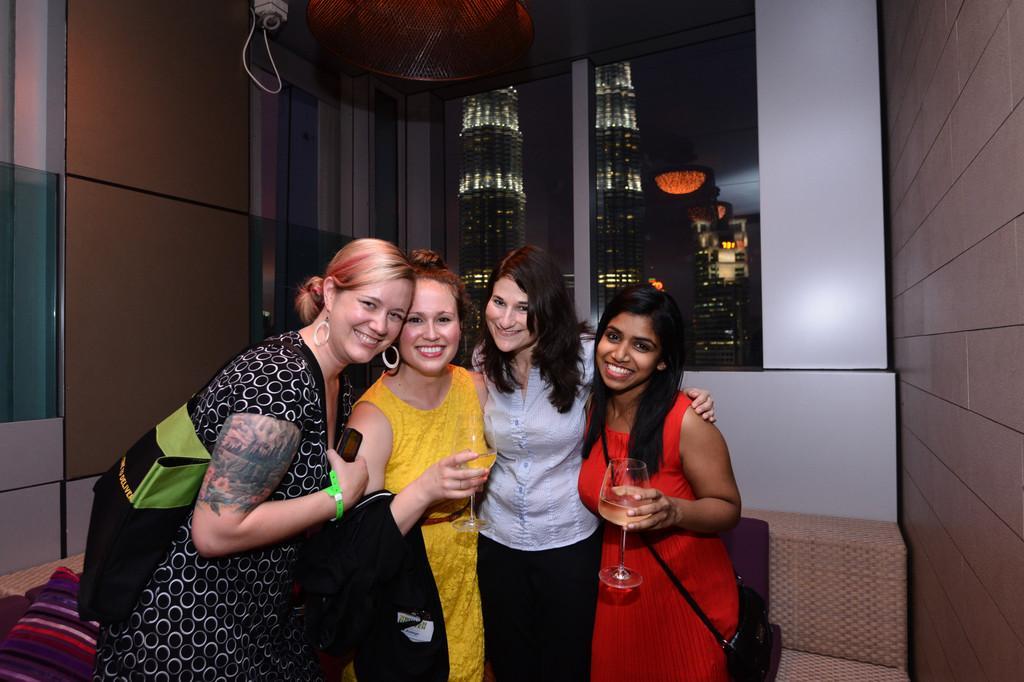How would you summarize this image in a sentence or two? In this picture there are women standing and smiling, among them there are two women holding glasses. We can see sofa, wall, objects and glass window, through this glass window we can see buildings and sky. 